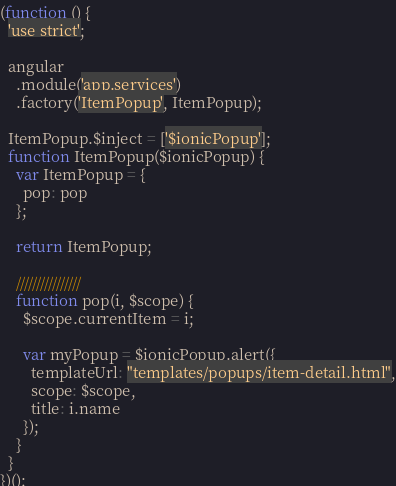Convert code to text. <code><loc_0><loc_0><loc_500><loc_500><_JavaScript_>(function () {
  'use strict';

  angular
    .module('app.services')
    .factory('ItemPopup', ItemPopup);

  ItemPopup.$inject = ['$ionicPopup'];
  function ItemPopup($ionicPopup) {
    var ItemPopup = {
      pop: pop
    };

    return ItemPopup;

    ////////////////
    function pop(i, $scope) {
      $scope.currentItem = i;

      var myPopup = $ionicPopup.alert({
        templateUrl: "templates/popups/item-detail.html",
        scope: $scope,
        title: i.name
      });
    }
  }
})();</code> 